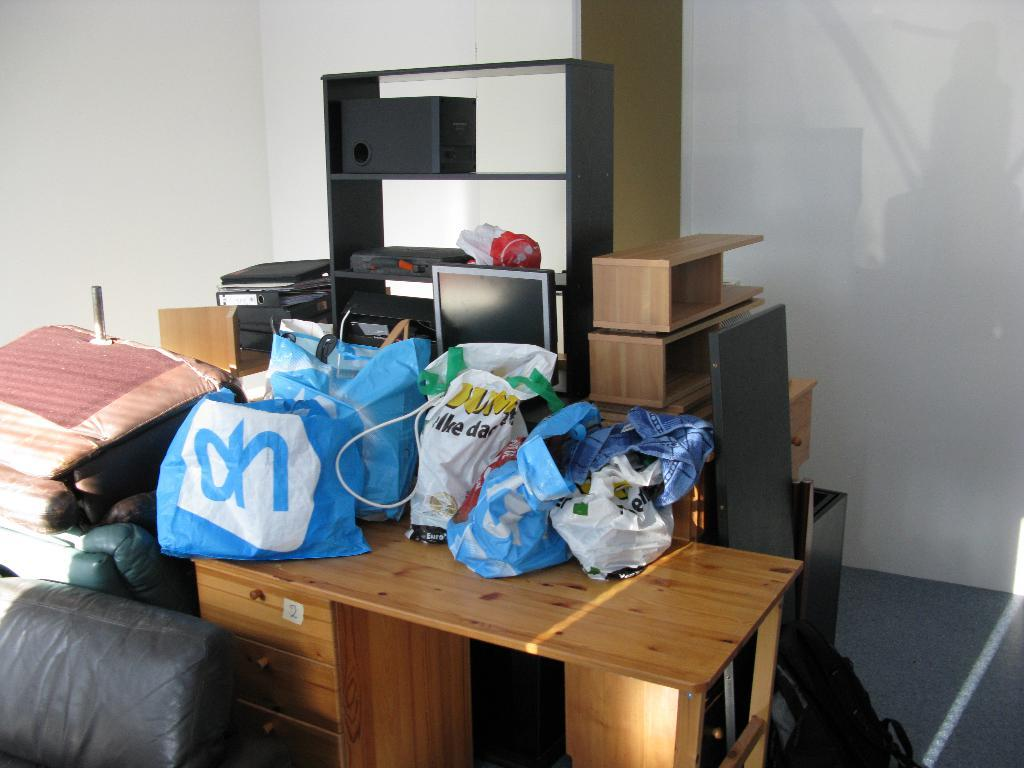<image>
Offer a succinct explanation of the picture presented. Blue bags with "oh" on it are on a wooden table in a cluttered room. 